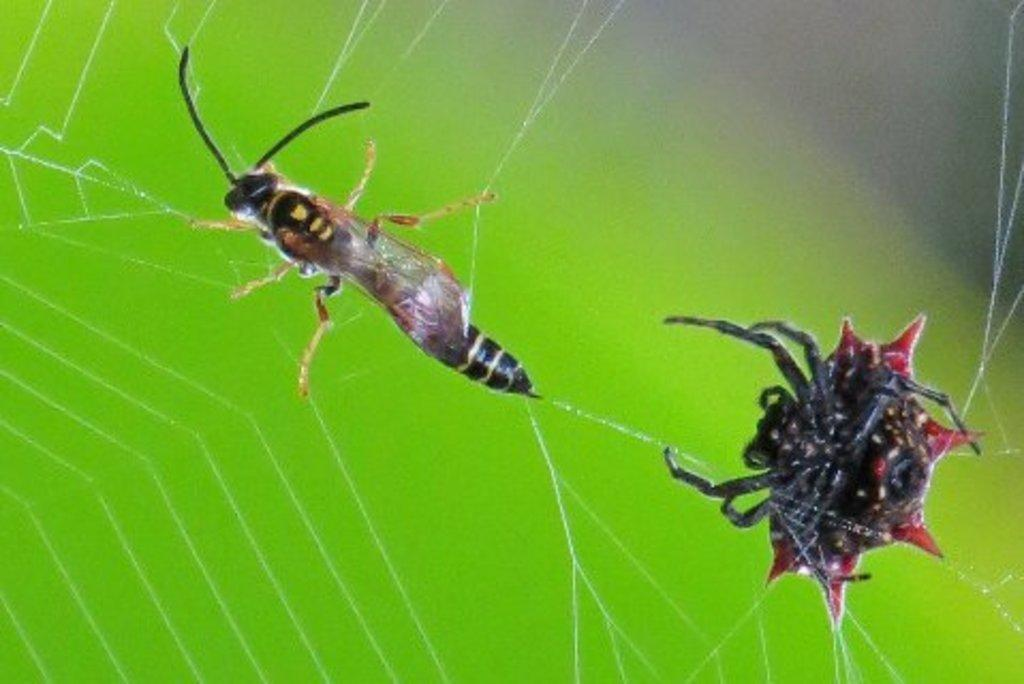What is the main subject of the image? The main subject of the image is a spider. What other creature is present in the image? There is a fly-like thing in the image. Where are the spider and the fly-like thing located? They are both on a spider net. How would you describe the overall appearance of the image? The background of the image is colored. What type of wheel can be seen in the image? There is no wheel present in the image. Is there a garden visible in the background of the image? The background of the image is colored, but there is no specific mention of a garden. 